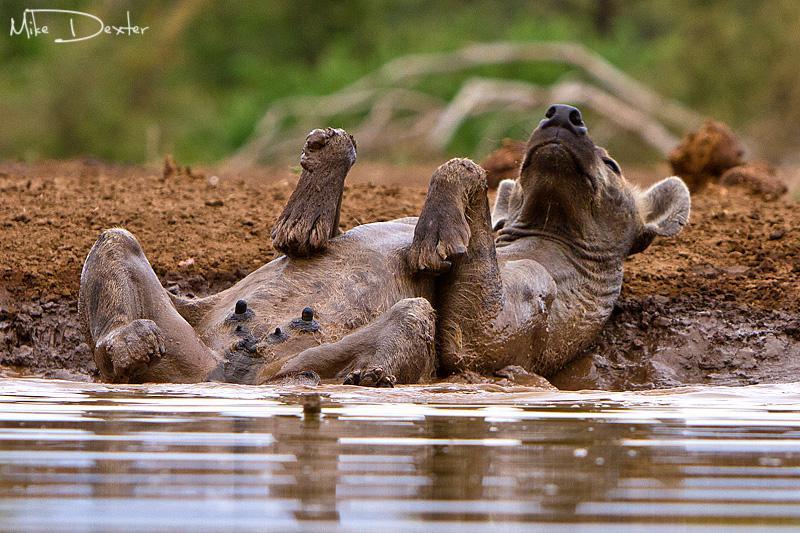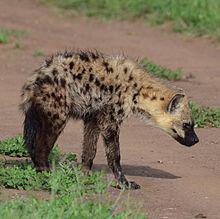The first image is the image on the left, the second image is the image on the right. Given the left and right images, does the statement "The combined images include a scene with a hyena at the edge of water and include a hyena lying on its back." hold true? Answer yes or no. Yes. The first image is the image on the left, the second image is the image on the right. Assess this claim about the two images: "The left image contains one hyena laying on its back.". Correct or not? Answer yes or no. Yes. 